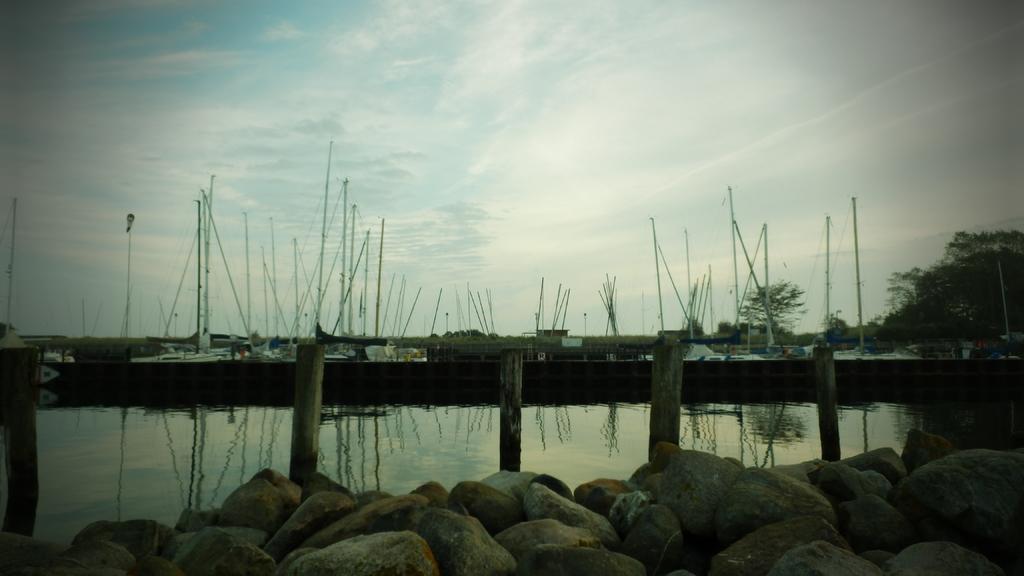Could you give a brief overview of what you see in this image? At the bottom of the image there are stones. Behind them there is water with poles. Behind them there is wooden deck. Behind the wooden deck there are boats with poles and ropes. At the top of the image there is sky. 